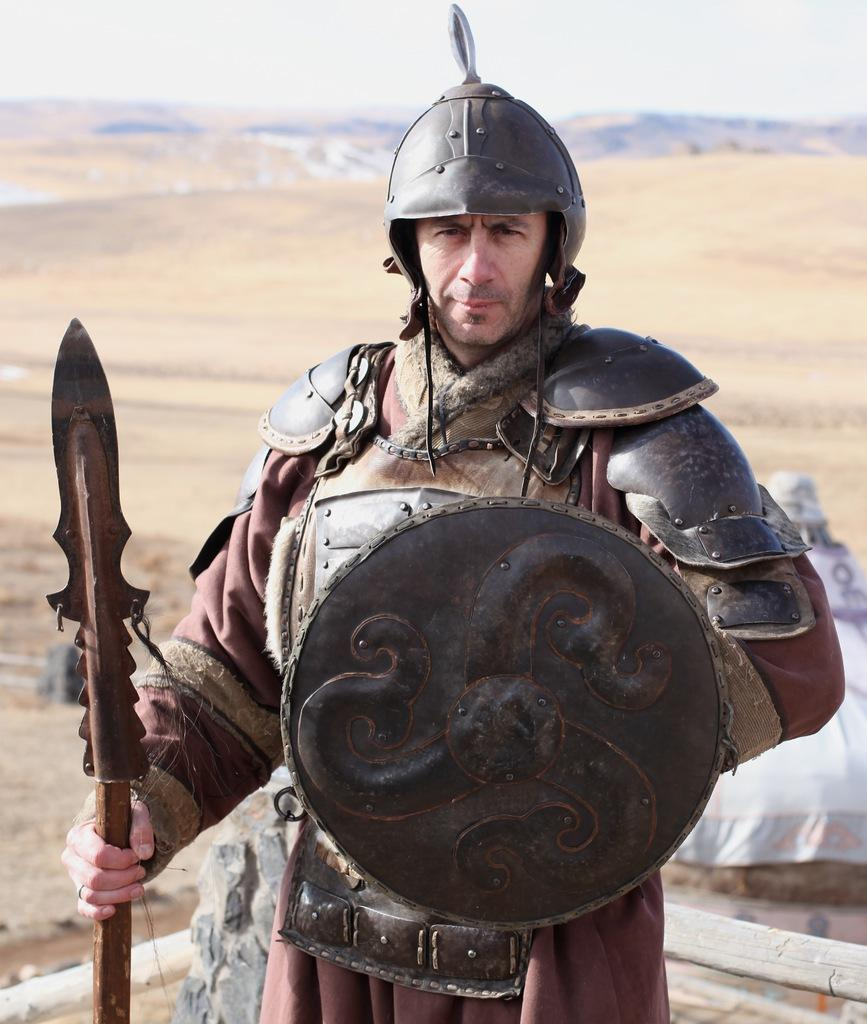What is the main subject of the image? There is a person standing in the image. What is the person wearing? The person is wearing a brown dress. What is the person holding in the image? The person is holding weapons. What can be seen in the background of the image? The background of the image includes sand in brown color and the sky in white color. How many snakes can be seen slithering through the trees in the image? There are no snakes or trees present in the image; it features a person standing with weapons against a background of sand and a white sky. 